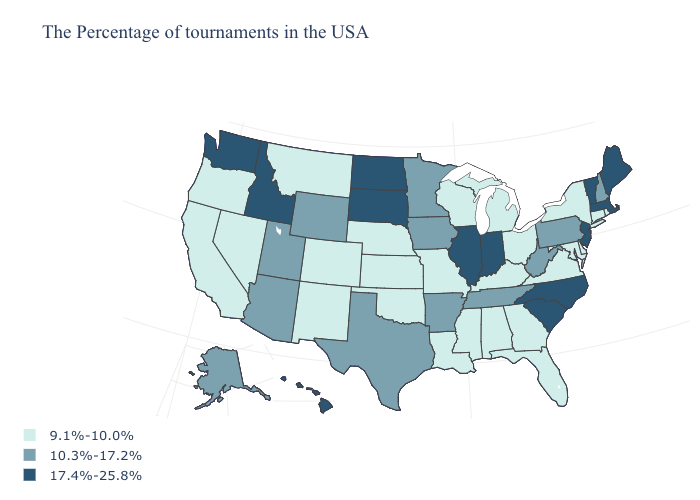Does Massachusetts have the highest value in the Northeast?
Keep it brief. Yes. Does Vermont have the lowest value in the Northeast?
Give a very brief answer. No. Which states have the lowest value in the Northeast?
Short answer required. Rhode Island, Connecticut, New York. Name the states that have a value in the range 9.1%-10.0%?
Be succinct. Rhode Island, Connecticut, New York, Delaware, Maryland, Virginia, Ohio, Florida, Georgia, Michigan, Kentucky, Alabama, Wisconsin, Mississippi, Louisiana, Missouri, Kansas, Nebraska, Oklahoma, Colorado, New Mexico, Montana, Nevada, California, Oregon. What is the value of Hawaii?
Short answer required. 17.4%-25.8%. What is the highest value in the USA?
Be succinct. 17.4%-25.8%. Among the states that border Kentucky , which have the highest value?
Be succinct. Indiana, Illinois. Which states have the highest value in the USA?
Keep it brief. Maine, Massachusetts, Vermont, New Jersey, North Carolina, South Carolina, Indiana, Illinois, South Dakota, North Dakota, Idaho, Washington, Hawaii. Among the states that border Connecticut , which have the highest value?
Keep it brief. Massachusetts. Name the states that have a value in the range 17.4%-25.8%?
Be succinct. Maine, Massachusetts, Vermont, New Jersey, North Carolina, South Carolina, Indiana, Illinois, South Dakota, North Dakota, Idaho, Washington, Hawaii. What is the value of South Carolina?
Keep it brief. 17.4%-25.8%. Name the states that have a value in the range 17.4%-25.8%?
Write a very short answer. Maine, Massachusetts, Vermont, New Jersey, North Carolina, South Carolina, Indiana, Illinois, South Dakota, North Dakota, Idaho, Washington, Hawaii. Among the states that border Connecticut , which have the lowest value?
Be succinct. Rhode Island, New York. Name the states that have a value in the range 9.1%-10.0%?
Concise answer only. Rhode Island, Connecticut, New York, Delaware, Maryland, Virginia, Ohio, Florida, Georgia, Michigan, Kentucky, Alabama, Wisconsin, Mississippi, Louisiana, Missouri, Kansas, Nebraska, Oklahoma, Colorado, New Mexico, Montana, Nevada, California, Oregon. Which states hav the highest value in the South?
Short answer required. North Carolina, South Carolina. 